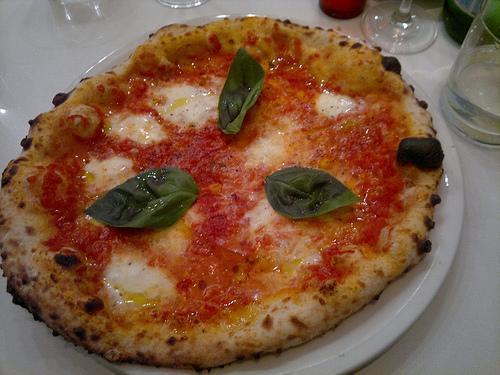How many pizzas are in the photo?
Give a very brief answer. 1. 